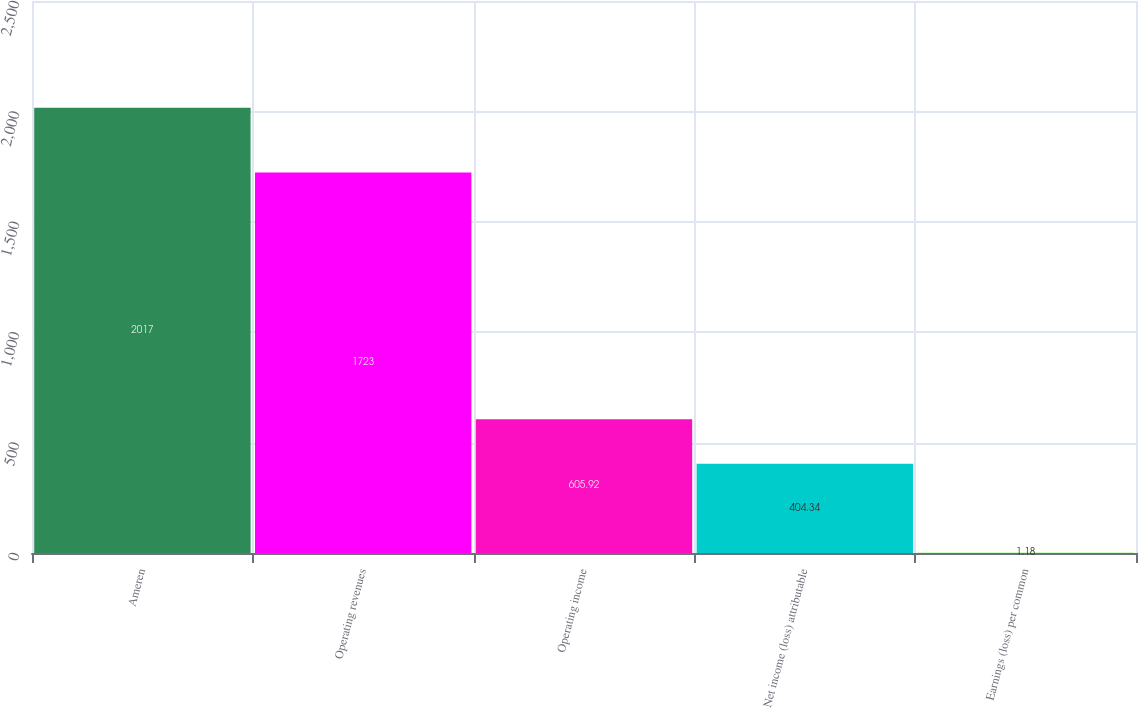<chart> <loc_0><loc_0><loc_500><loc_500><bar_chart><fcel>Ameren<fcel>Operating revenues<fcel>Operating income<fcel>Net income (loss) attributable<fcel>Earnings (loss) per common<nl><fcel>2017<fcel>1723<fcel>605.92<fcel>404.34<fcel>1.18<nl></chart> 